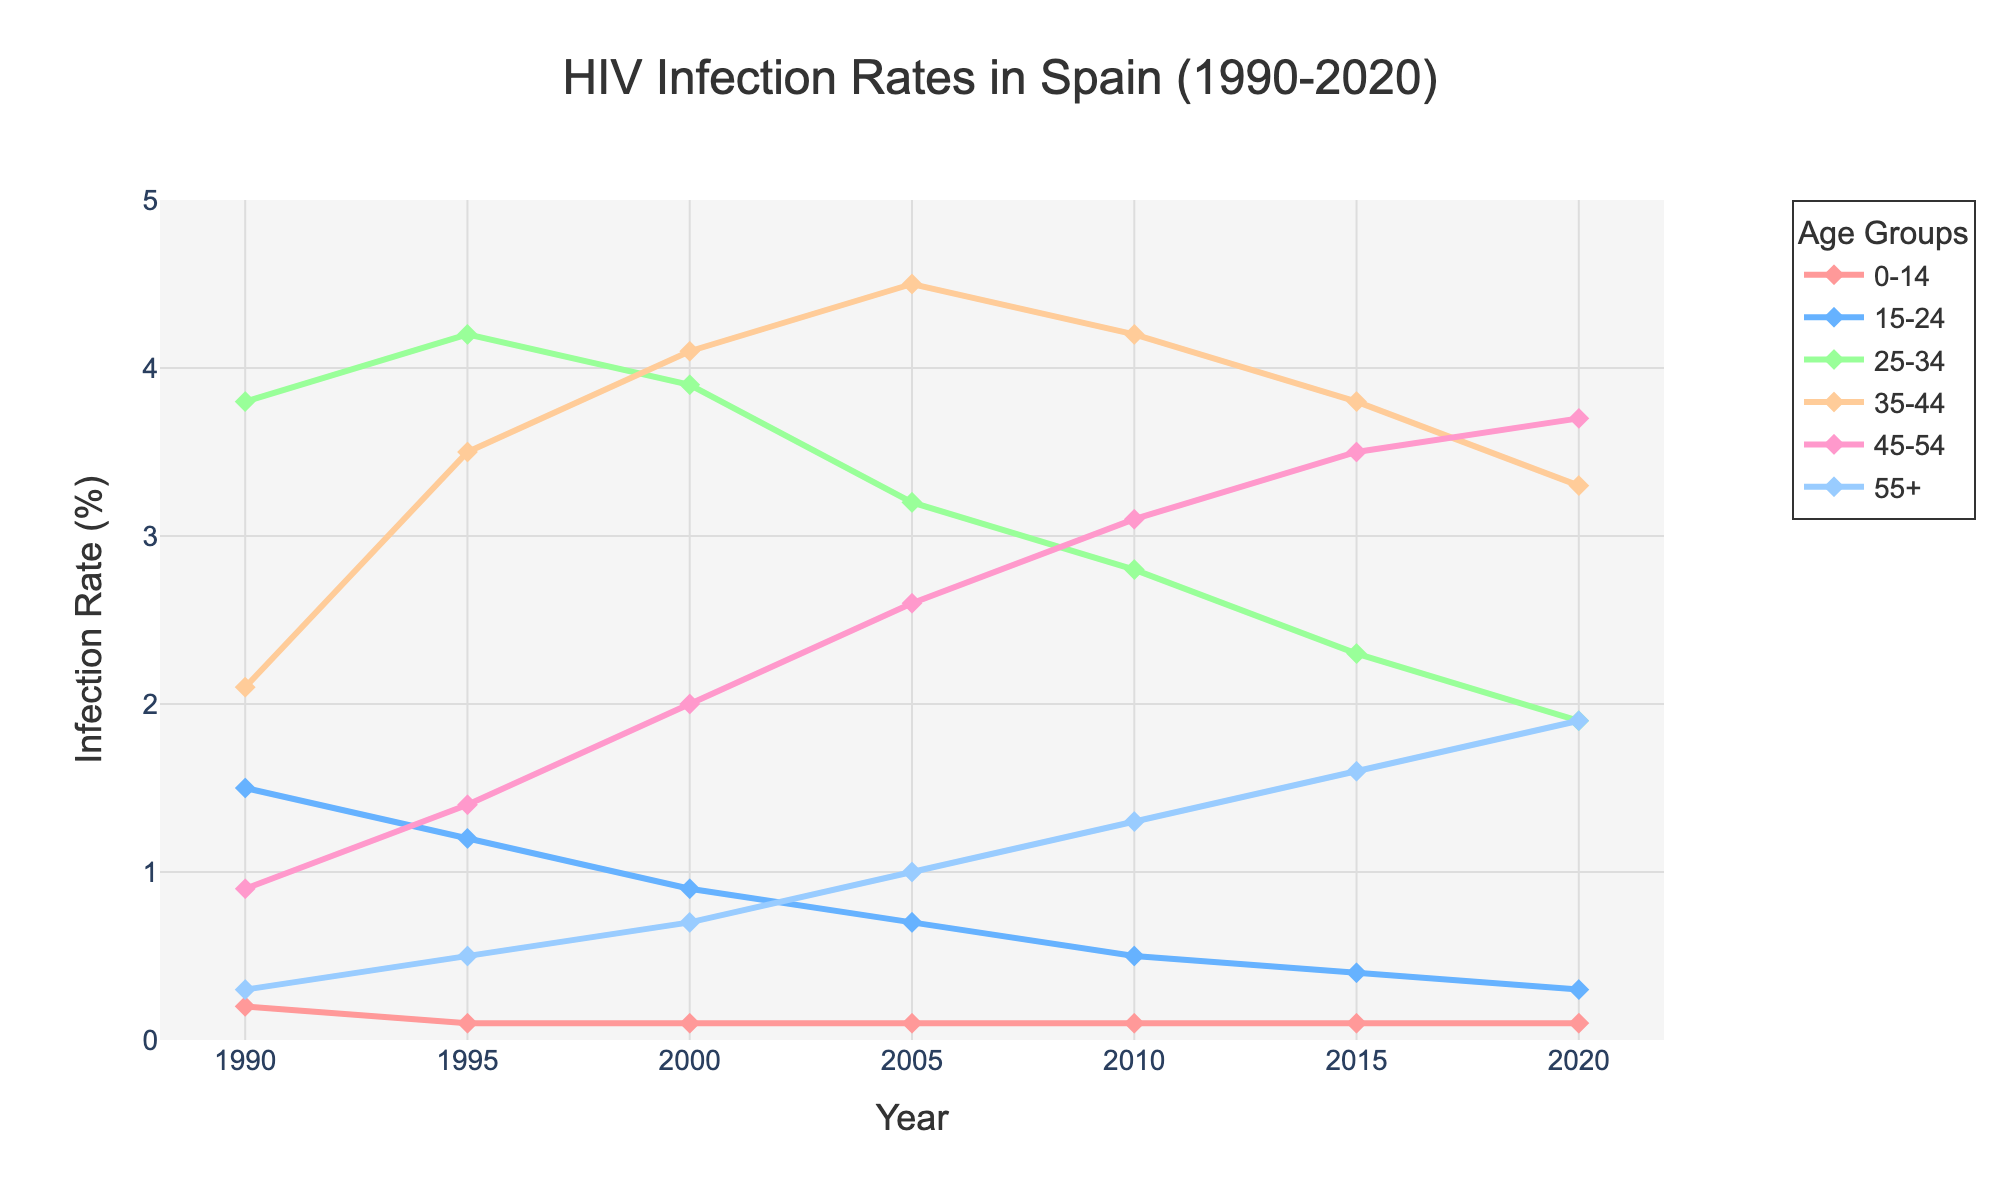What is the trend in HIV infection rates for the age group 25-34 from 1990 to 2020? The figure shows a decreasing pattern. In 1990, the rate was at 3.8%, then it rose slightly in 1995 to 4.2%. After 1995, there was a consistent decline until 2020, where the infection rate reduced to 1.9%.
Answer: Decreasing Which age group had the highest HIV infection rate in 2010? Observing the values in the figure for 2010, the age group 35-44 had the highest infection rate at 4.2%.
Answer: 35-44 Compare the change in HIV infection rates for the 15-24 and 45-54 age groups from 1990 to 2020. For the 15-24 age group, the infection rate declined from 1.5% in 1990 to 0.3% in 2020. For the 45-54 age group, the rate increased from 0.9% in 1990 to 3.7% in 2020.
Answer: 15-24 decreased; 45-54 increased Which age group showed the most consistent increase in HIV infection rates from 1990 to 2020? The 55+ age group showed the most consistent increase in HIV infection rates, rising from 0.3% in 1990 to 1.9% in 2020.
Answer: 55+ What was the infection rate difference between the highest and second-highest age groups in 2005? In 2005, the 35-44 age group had the highest rate at 4.5%, while the 45-54 age group was second-highest at 2.6%. The difference is 4.5% - 2.6% = 1.9%.
Answer: 1.9% What is the average infection rate for the 35-44 age group across the recorded years? The infection rates for the 35-44 age group are: 2.1%, 3.5%, 4.1%, 4.5%, 4.2%, 3.8%, 3.3%. Summing these values gives 25.5, and the average is 25.5 / 7 = 3.64%.
Answer: 3.64% Which age group had the least variation in HIV infection rates from 1990 to 2020? The 0-14 age group remained relatively constant at around 0.1% throughout the years.
Answer: 0-14 Between 1995 and 2005, which age group experienced the greatest increase in infection rates? The age group 35-44 experienced the greatest increase in infection rates, from 3.5% in 1995 to 4.5% in 2005, a change of 1%.
Answer: 35-44 How did the infection rates for the 15-24 age group change relative to the overall trend from 1990 to 2020? The 15-24 age group showed a consistent decline from 1.5% in 1990 to 0.3% in 2020, which is contrary to the increasing trend observed in some other age groups.
Answer: Declined 